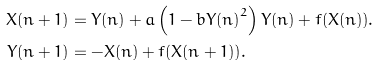<formula> <loc_0><loc_0><loc_500><loc_500>X ( n + 1 ) & = Y ( n ) + a \left ( 1 - b Y { ( n ) } ^ { 2 } \right ) Y { ( n ) } + f ( X ( n ) ) . \\ Y ( n + 1 ) & = - X ( n ) + f ( X ( n + 1 ) ) .</formula> 